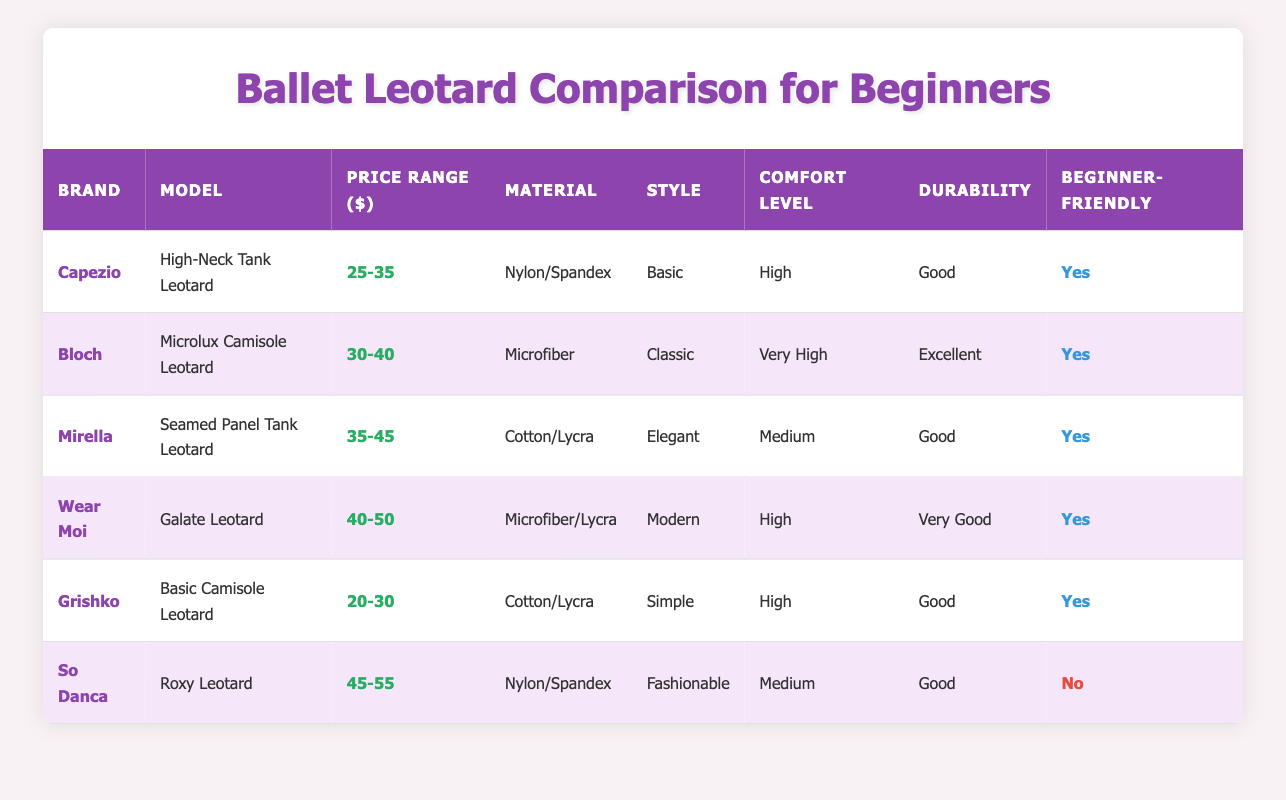What is the price range of the Capezio High-Neck Tank Leotard? The table lists the Capezio High-Neck Tank Leotard under the "Price Range ($)" column, revealing that it is priced between 25 and 35 dollars.
Answer: 25-35 Which brand offers the most expensive leotard? Examining the "Price Range ($)" column, the highest value listed is from So Danca, which has a price range of 45-55 dollars.
Answer: So Danca How many leotards are beginner-friendly? By checking the "Beginner-Friendly" column, five out of the six leotards listed are marked as "Yes," indicating that they are beginner-friendly.
Answer: 5 Which leotard has the highest comfort level rating? The "Comfort Level" column shows that the Bloch Microlux Camisole Leotard is rated as "Very High," which is the highest rating present in the table.
Answer: Bloch Microlux Camisole Leotard What is the average price range of the listed leotards? The price ranges of the leotards are: 25-35, 30-40, 35-45, 40-50, 20-30, and 45-55. Converting these ranges to their numeric averages, we get (30 + 35 + 40 + 45 + 25 + 50) / 6 = 36.67, rounded to two decimal places gives approximately 36.67.
Answer: 36.67 Are all leotards made from synthetic materials? The material properties listed show that two leotards (Grishko Basic Camisole Leotard and Mirella Seamed Panel Tank Leotard) are made from cotton blends, showing that not all materials are synthetic.
Answer: No Which leotard is both fashionable and beginner-friendly? Checking the "Style" and "Beginner-Friendly" columns, the So Danca Roxy Leotard is listed as fashionable but it is marked as "No" for being beginner-friendly, indicating that no fashionable leotard is marked as beginner-friendly.
Answer: None Which brand has the highest durability rating? The table states that the Bloch Microlux Camisole Leotard is rated "Excellent" in durability, making it the highest among all the options.
Answer: Bloch Microlux Camisole Leotard 